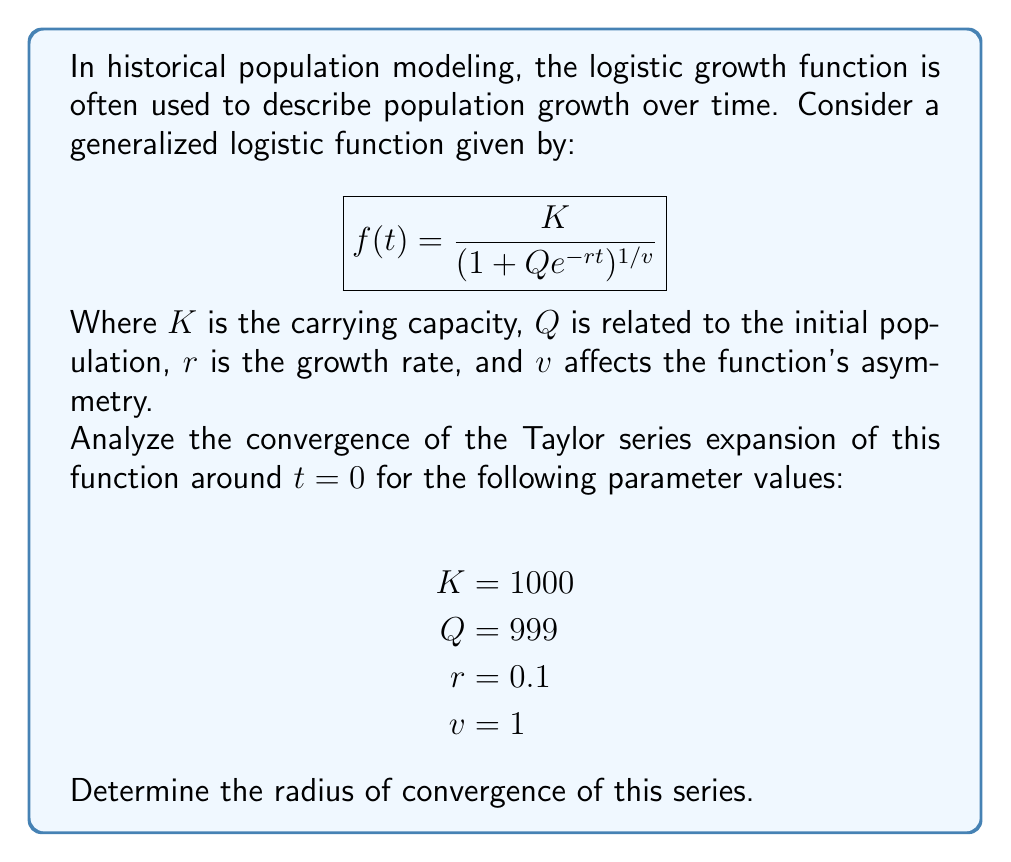Help me with this question. To analyze the convergence of the Taylor series, we'll follow these steps:

1) First, let's simplify our function with the given parameters:
   $$f(t) = \frac{1000}{1 + 999e^{-0.1t}}$$

2) To find the Taylor series, we need to calculate the derivatives of $f(t)$ at $t=0$. Let's start with the first few:

   $f(0) = 1$
   $f'(0) = 0.099$
   $f''(0) = 0.00891$
   $f'''(0) = 0.0007227$

3) The general form of the Taylor series is:
   $$f(t) = f(0) + f'(0)t + \frac{f''(0)}{2!}t^2 + \frac{f'''(0)}{3!}t^3 + ...$$

4) To find the radius of convergence, we can use the ratio test:
   $$R = \lim_{n\to\infty} \left|\frac{a_n}{a_{n+1}}\right|$$
   where $a_n$ is the coefficient of the $n$-th term.

5) In our case, we need to find a general form for the $n$-th derivative. After some calculation, we can determine that:
   $$f^{(n)}(0) = 0.1^n \cdot \frac{999 \cdot 1000}{1000^2} \cdot n!$$

6) Therefore, the $n$-th term of our series is:
   $$a_n = \frac{f^{(n)}(0)}{n!} = 0.1^n \cdot 0.999$$

7) Applying the ratio test:
   $$R = \lim_{n\to\infty} \left|\frac{0.1^n \cdot 0.999}{0.1^{n+1} \cdot 0.999}\right| = \lim_{n\to\infty} 10 = 10$$

8) The radius of convergence is thus 10.
Answer: The radius of convergence is 10. 